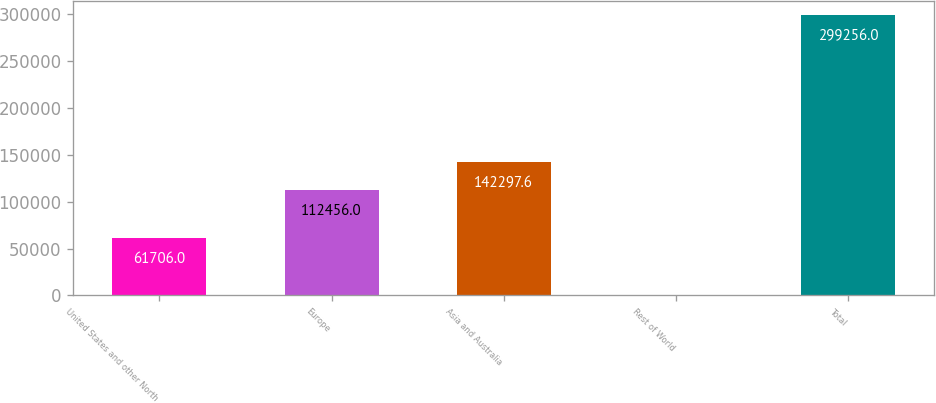<chart> <loc_0><loc_0><loc_500><loc_500><bar_chart><fcel>United States and other North<fcel>Europe<fcel>Asia and Australia<fcel>Rest of World<fcel>Total<nl><fcel>61706<fcel>112456<fcel>142298<fcel>840<fcel>299256<nl></chart> 